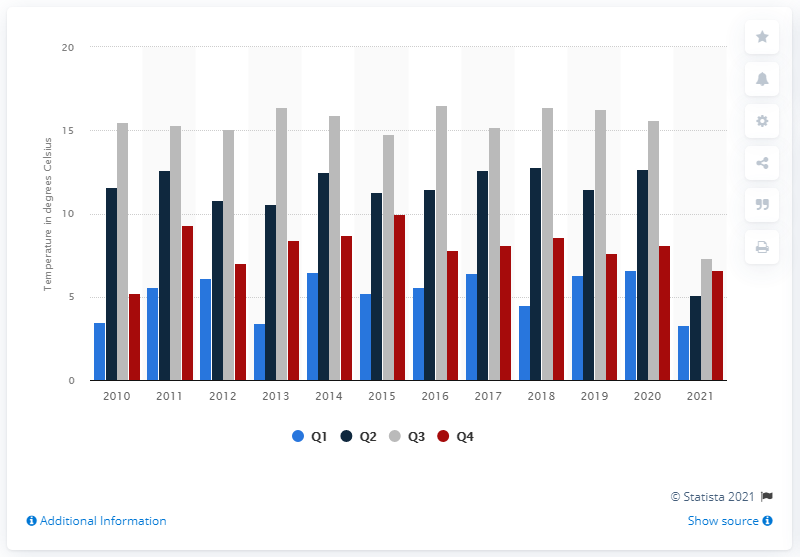Point out several critical features in this image. In 2016, the highest temperature was recorded in the United Kingdom. 